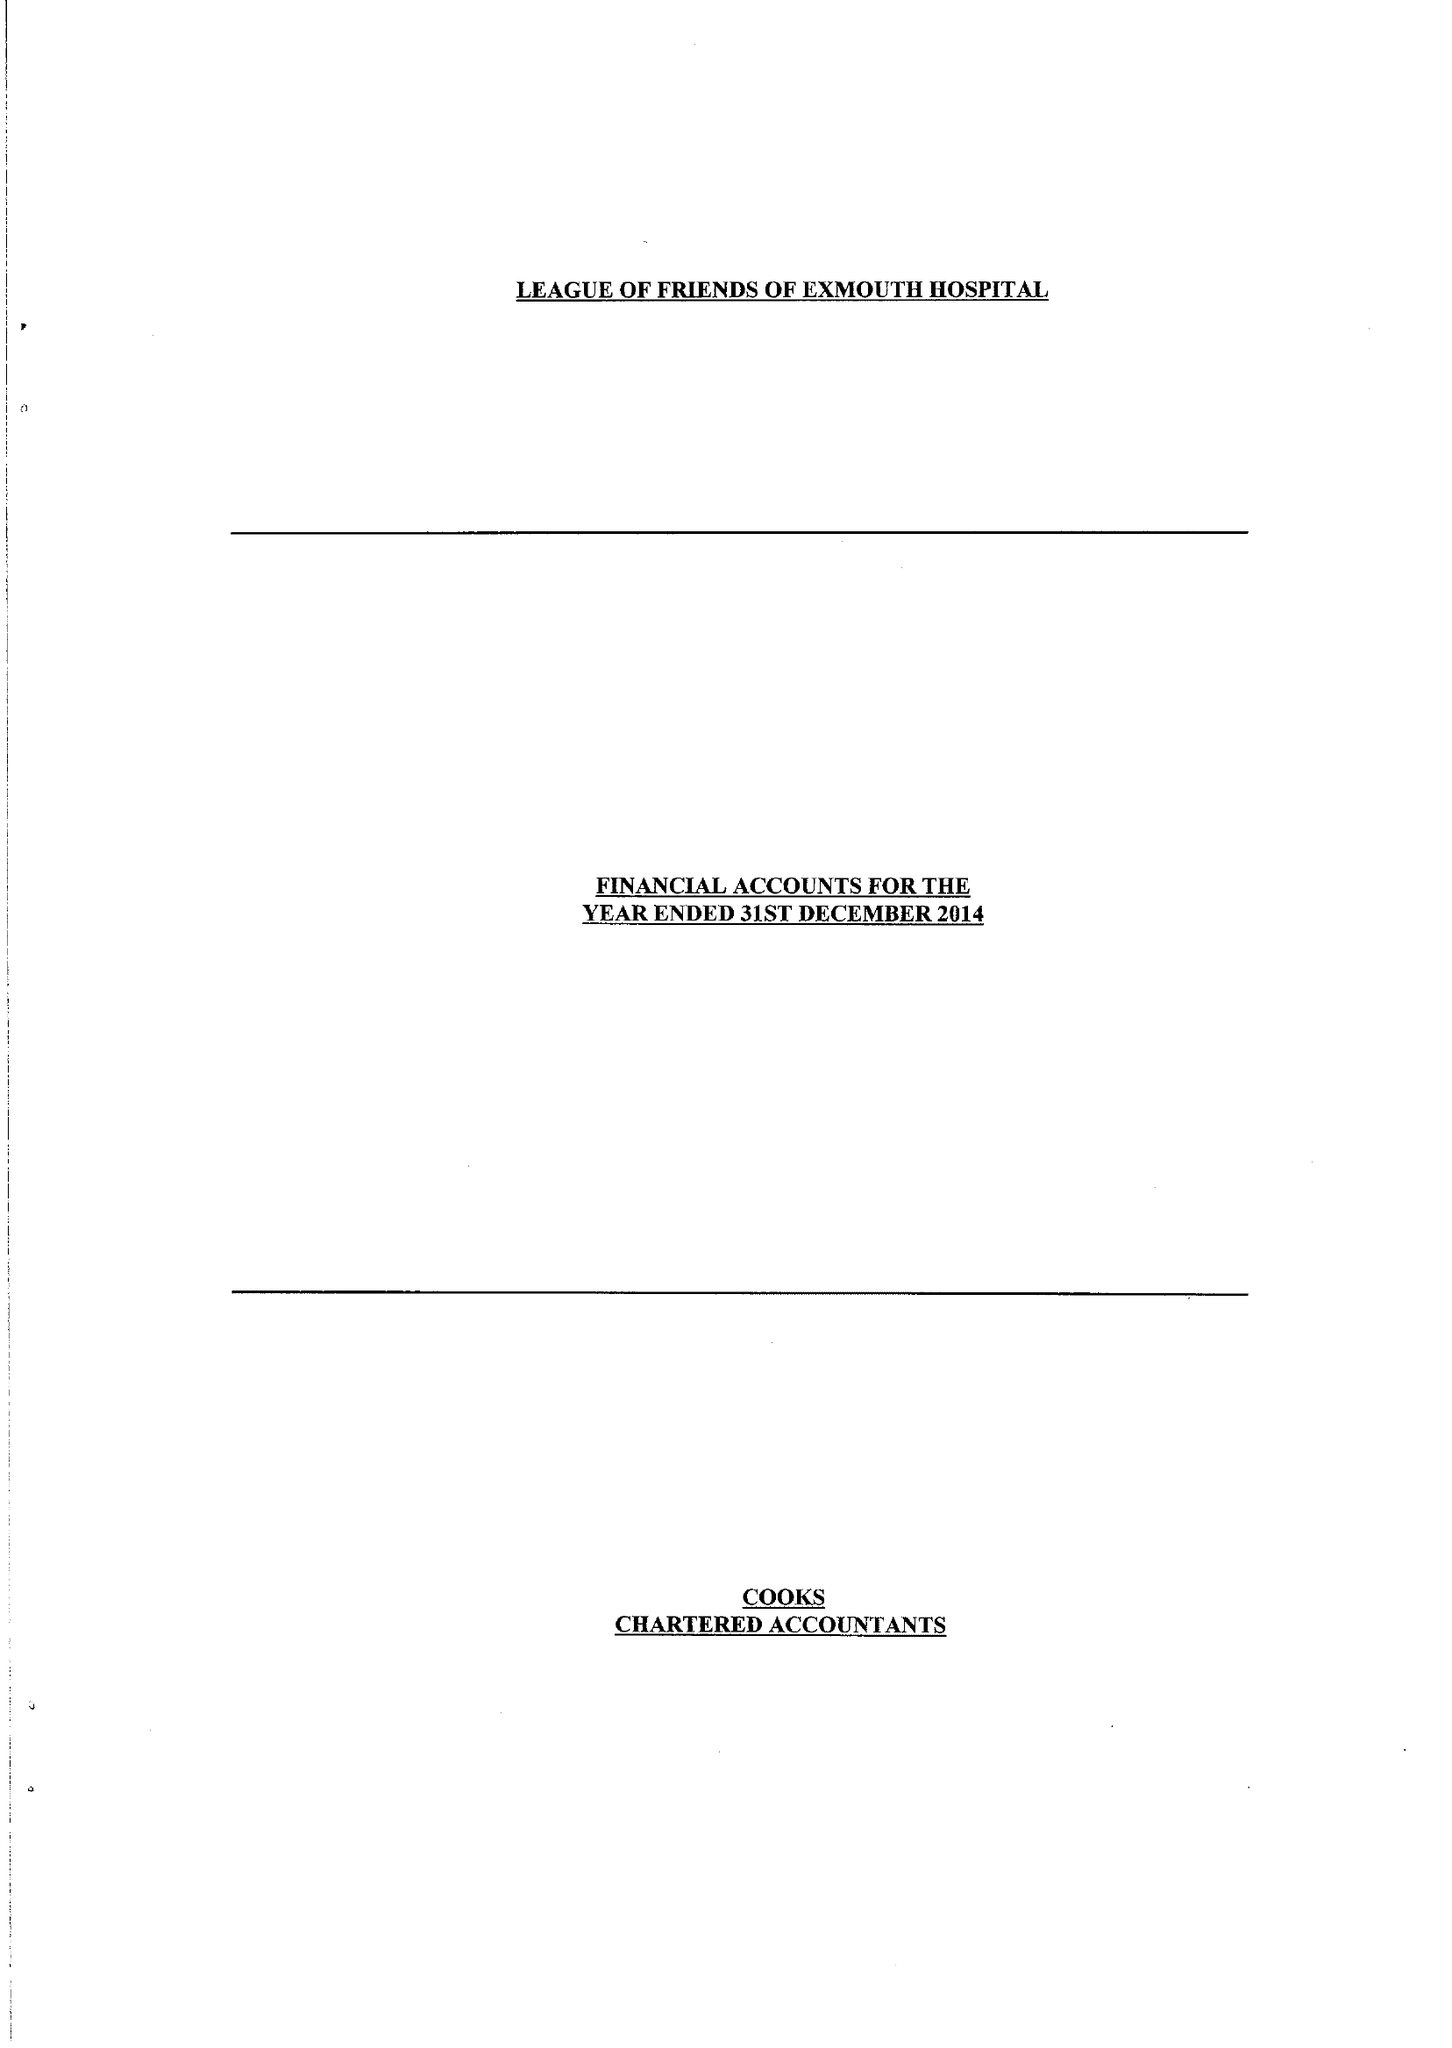What is the value for the address__postcode?
Answer the question using a single word or phrase. EX8 2DW 